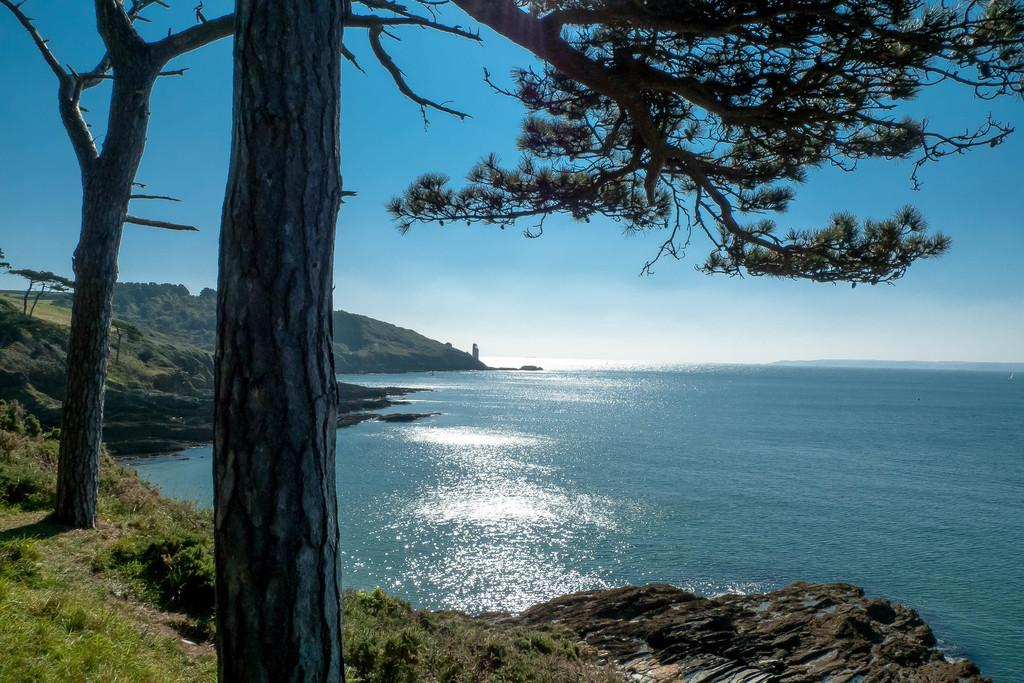What type of vegetation can be seen in the image? There are trees in the image. What else can be seen on the ground in the image? There is grass in the image. What is the water feature in the image? The water is visible in the image. What color is the sky in the image? The sky is blue in color. What type of secretary can be seen working in the image? There is no secretary present in the image; it features natural elements such as trees, grass, water, and a blue sky. What time of day is it in the image, given that it is night? The image does not depict nighttime, as the sky is blue in color, which typically indicates daytime. 